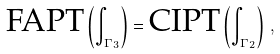<formula> <loc_0><loc_0><loc_500><loc_500>\text {FAPT} \left ( \int _ { \Gamma _ { 3 } } \right ) = \text {CIPT} \left ( \int _ { \Gamma _ { 2 } } \right ) \, ,</formula> 